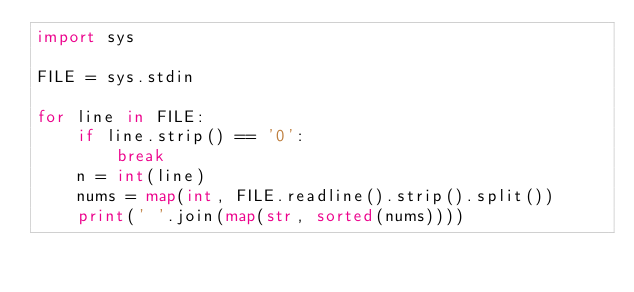<code> <loc_0><loc_0><loc_500><loc_500><_Python_>import sys

FILE = sys.stdin

for line in FILE:
    if line.strip() == '0':
        break
    n = int(line)
    nums = map(int, FILE.readline().strip().split())
    print(' '.join(map(str, sorted(nums))))
</code> 